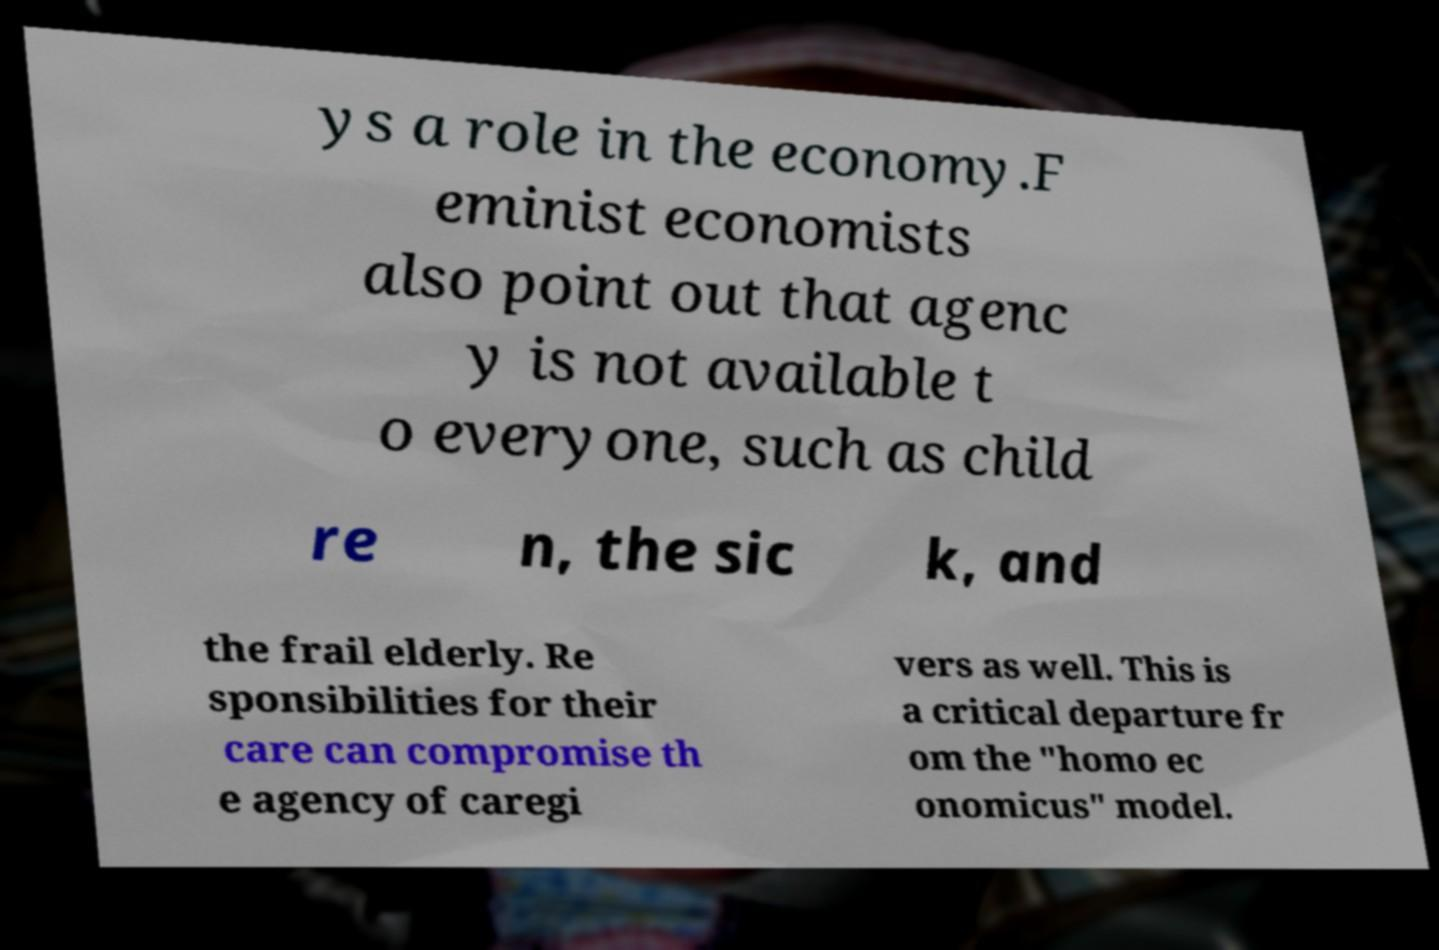I need the written content from this picture converted into text. Can you do that? ys a role in the economy.F eminist economists also point out that agenc y is not available t o everyone, such as child re n, the sic k, and the frail elderly. Re sponsibilities for their care can compromise th e agency of caregi vers as well. This is a critical departure fr om the "homo ec onomicus" model. 